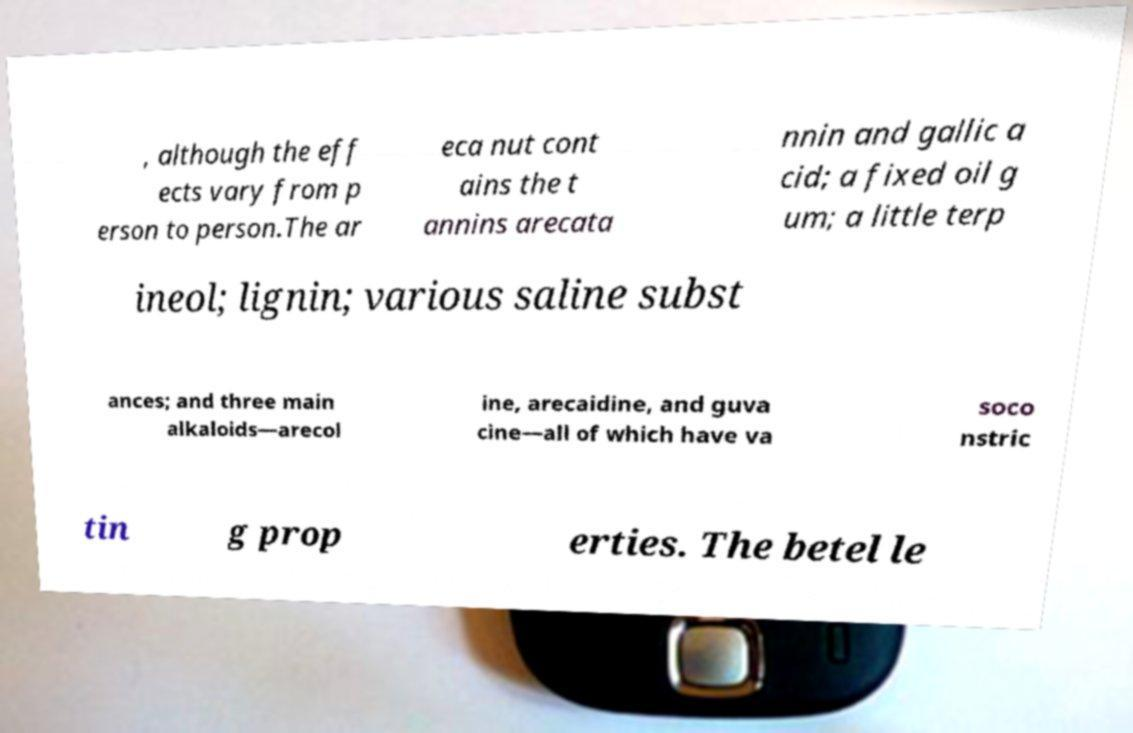Please read and relay the text visible in this image. What does it say? , although the eff ects vary from p erson to person.The ar eca nut cont ains the t annins arecata nnin and gallic a cid; a fixed oil g um; a little terp ineol; lignin; various saline subst ances; and three main alkaloids—arecol ine, arecaidine, and guva cine—all of which have va soco nstric tin g prop erties. The betel le 